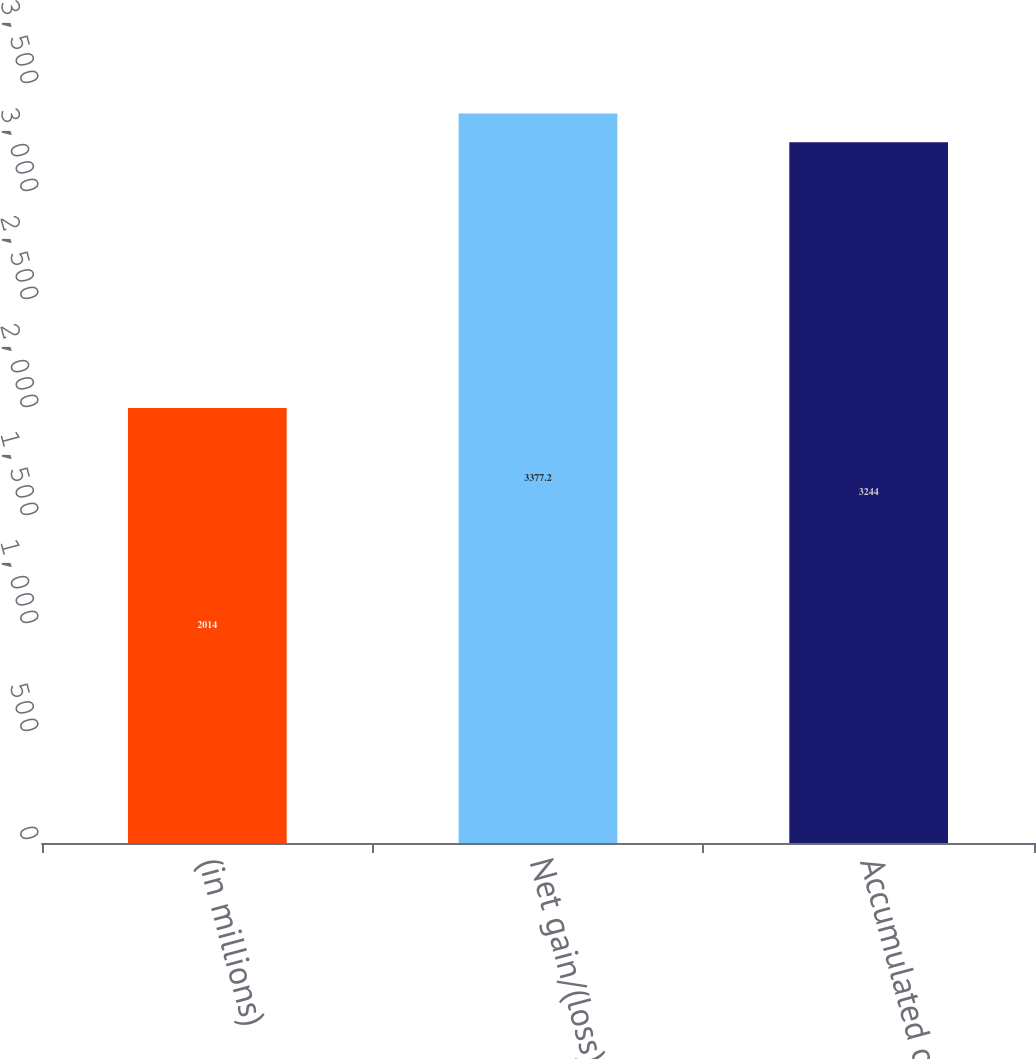<chart> <loc_0><loc_0><loc_500><loc_500><bar_chart><fcel>(in millions)<fcel>Net gain/(loss)<fcel>Accumulated other<nl><fcel>2014<fcel>3377.2<fcel>3244<nl></chart> 